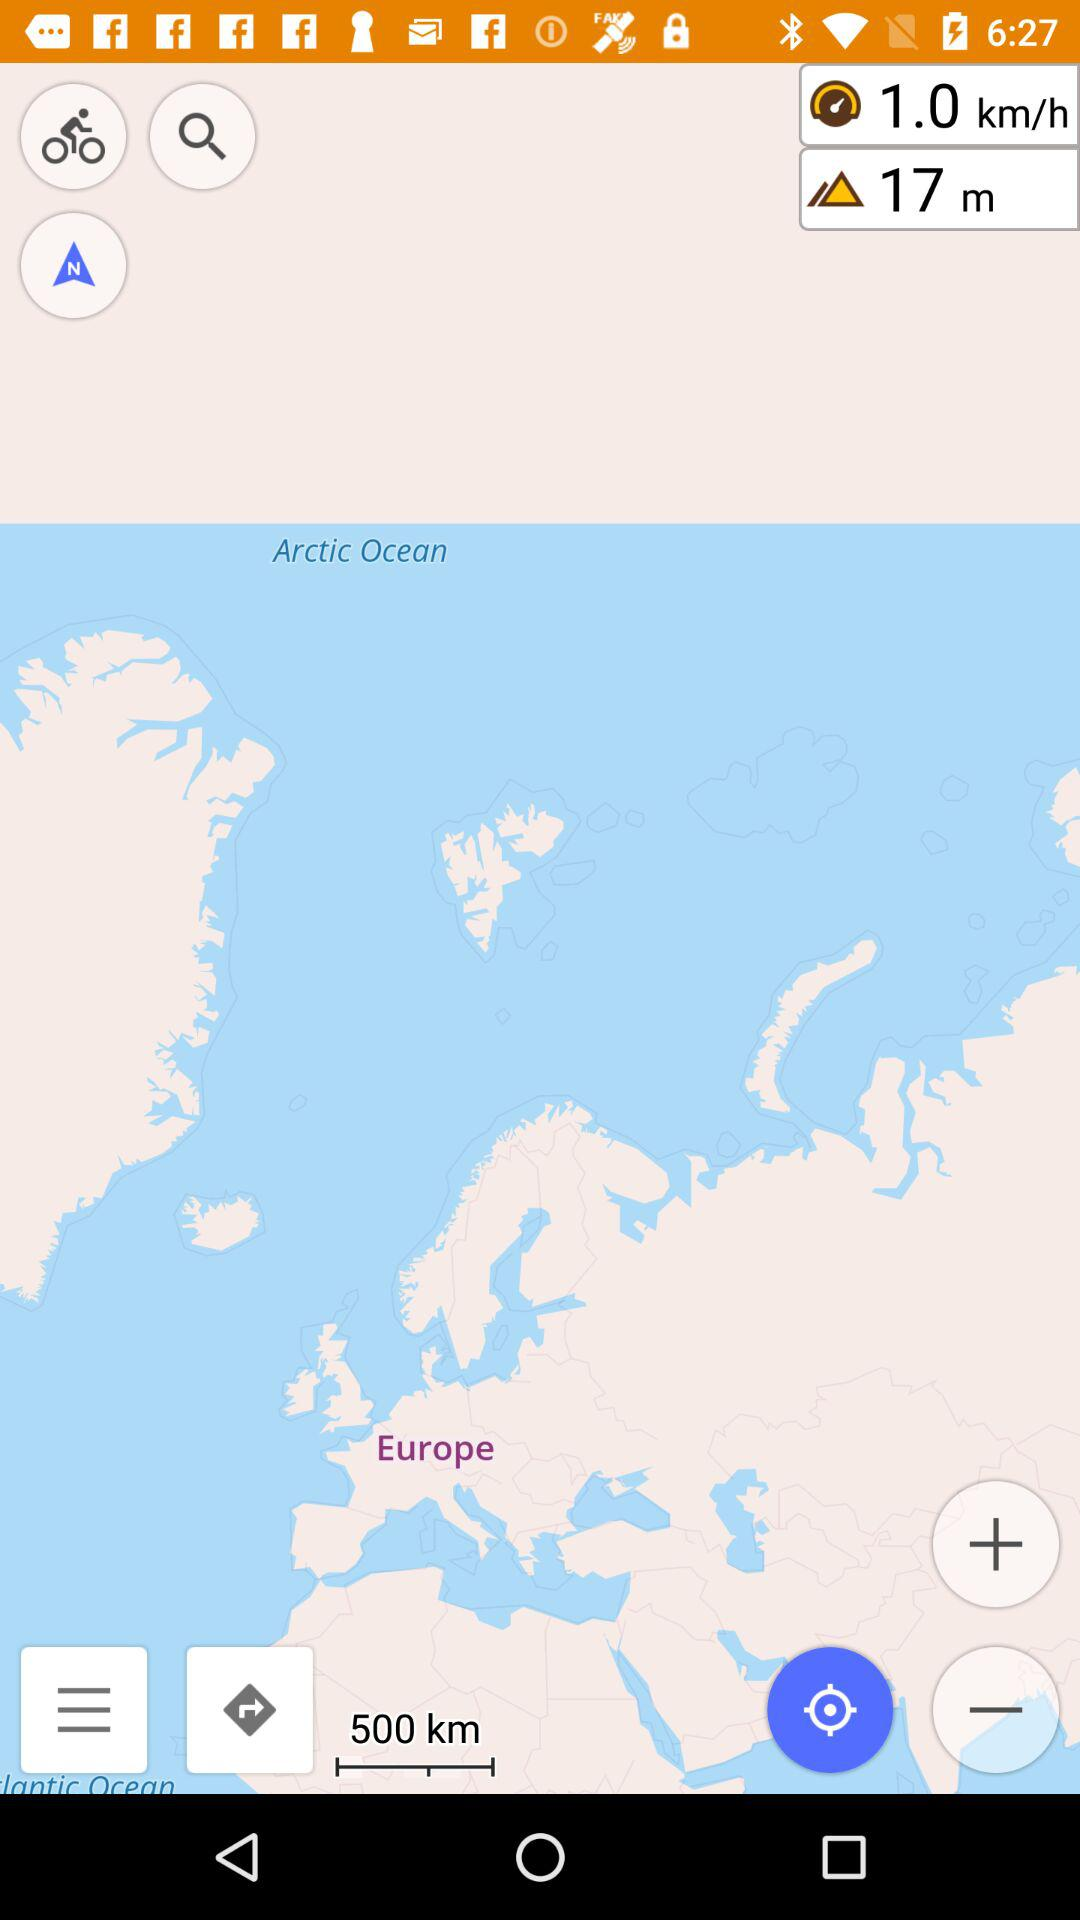How many more meters than kilometers are shown on the map?
Answer the question using a single word or phrase. 17 